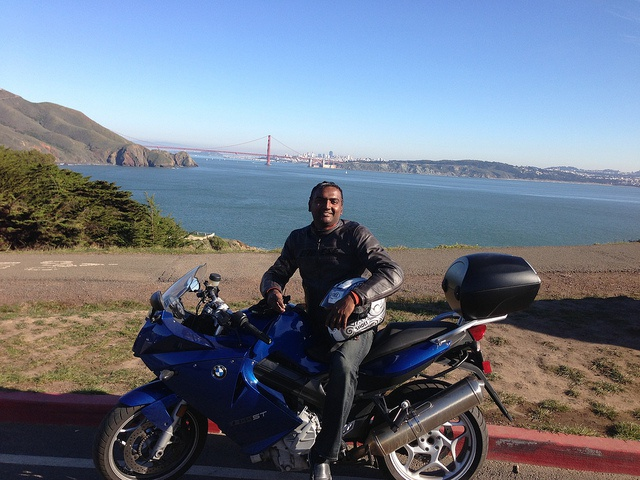Describe the objects in this image and their specific colors. I can see motorcycle in lightblue, black, gray, navy, and darkgray tones and people in lightblue, black, gray, and darkgray tones in this image. 